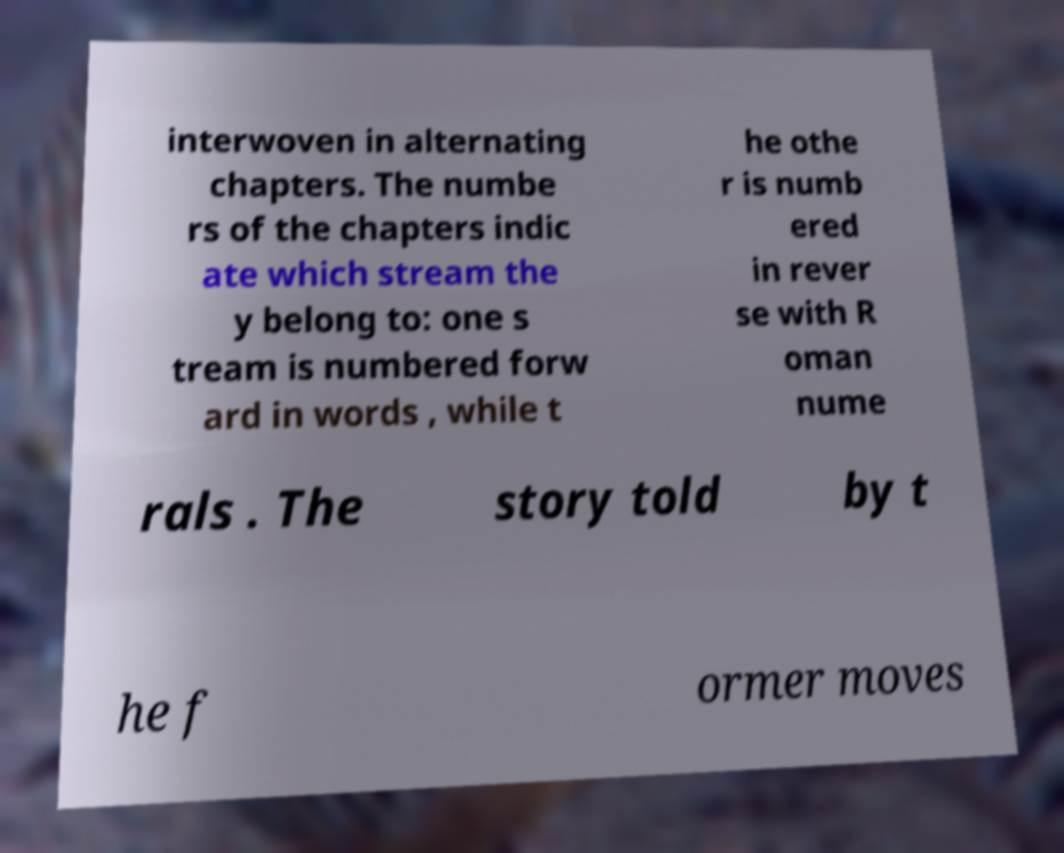Please read and relay the text visible in this image. What does it say? interwoven in alternating chapters. The numbe rs of the chapters indic ate which stream the y belong to: one s tream is numbered forw ard in words , while t he othe r is numb ered in rever se with R oman nume rals . The story told by t he f ormer moves 